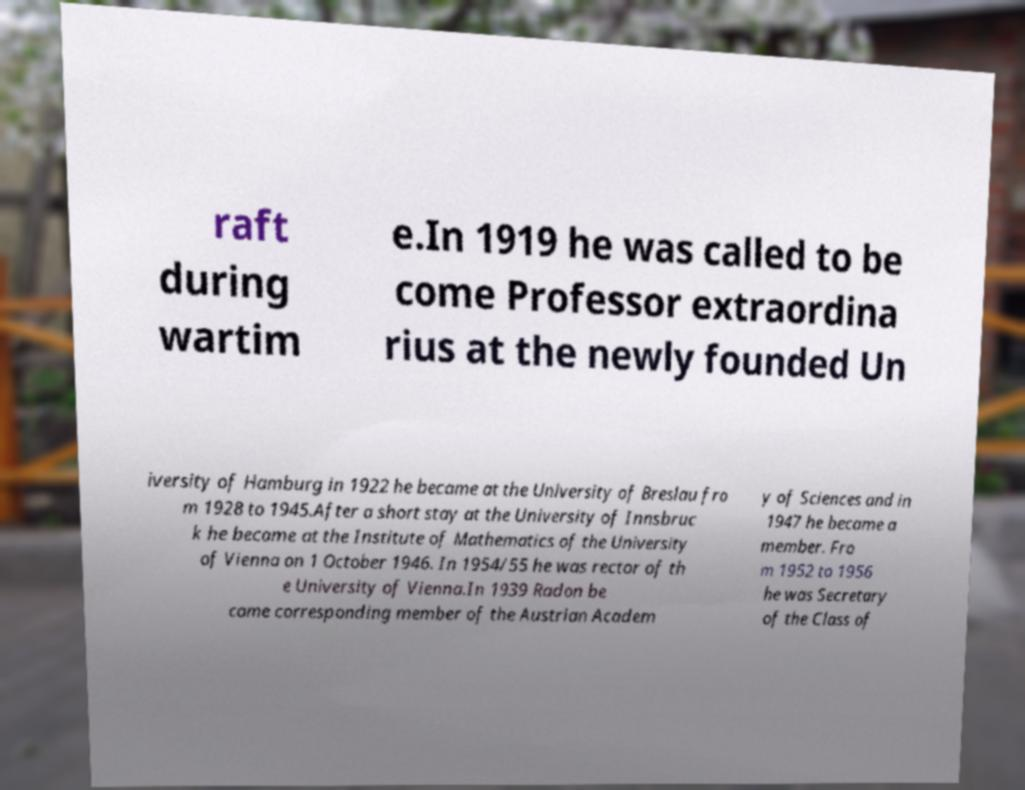Could you extract and type out the text from this image? raft during wartim e.In 1919 he was called to be come Professor extraordina rius at the newly founded Un iversity of Hamburg in 1922 he became at the University of Breslau fro m 1928 to 1945.After a short stay at the University of Innsbruc k he became at the Institute of Mathematics of the University of Vienna on 1 October 1946. In 1954/55 he was rector of th e University of Vienna.In 1939 Radon be came corresponding member of the Austrian Academ y of Sciences and in 1947 he became a member. Fro m 1952 to 1956 he was Secretary of the Class of 